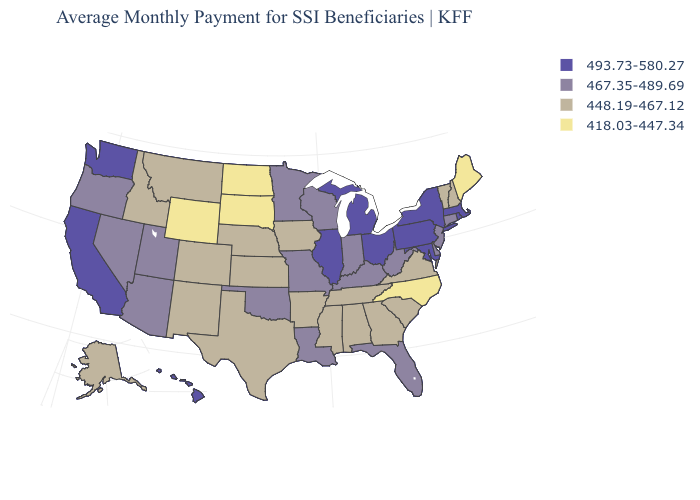Name the states that have a value in the range 418.03-447.34?
Quick response, please. Maine, North Carolina, North Dakota, South Dakota, Wyoming. Name the states that have a value in the range 448.19-467.12?
Write a very short answer. Alabama, Alaska, Arkansas, Colorado, Georgia, Idaho, Iowa, Kansas, Mississippi, Montana, Nebraska, New Hampshire, New Mexico, South Carolina, Tennessee, Texas, Vermont, Virginia. What is the value of Maine?
Give a very brief answer. 418.03-447.34. What is the value of Alaska?
Keep it brief. 448.19-467.12. Among the states that border Arkansas , which have the lowest value?
Be succinct. Mississippi, Tennessee, Texas. Does the map have missing data?
Concise answer only. No. Name the states that have a value in the range 493.73-580.27?
Write a very short answer. California, Hawaii, Illinois, Maryland, Massachusetts, Michigan, New York, Ohio, Pennsylvania, Rhode Island, Washington. Name the states that have a value in the range 448.19-467.12?
Give a very brief answer. Alabama, Alaska, Arkansas, Colorado, Georgia, Idaho, Iowa, Kansas, Mississippi, Montana, Nebraska, New Hampshire, New Mexico, South Carolina, Tennessee, Texas, Vermont, Virginia. What is the value of Tennessee?
Quick response, please. 448.19-467.12. Does Oklahoma have the same value as Minnesota?
Keep it brief. Yes. Does Missouri have the same value as New Jersey?
Concise answer only. Yes. Does Wyoming have the same value as California?
Give a very brief answer. No. What is the highest value in states that border Nebraska?
Quick response, please. 467.35-489.69. Name the states that have a value in the range 448.19-467.12?
Quick response, please. Alabama, Alaska, Arkansas, Colorado, Georgia, Idaho, Iowa, Kansas, Mississippi, Montana, Nebraska, New Hampshire, New Mexico, South Carolina, Tennessee, Texas, Vermont, Virginia. Name the states that have a value in the range 418.03-447.34?
Answer briefly. Maine, North Carolina, North Dakota, South Dakota, Wyoming. 